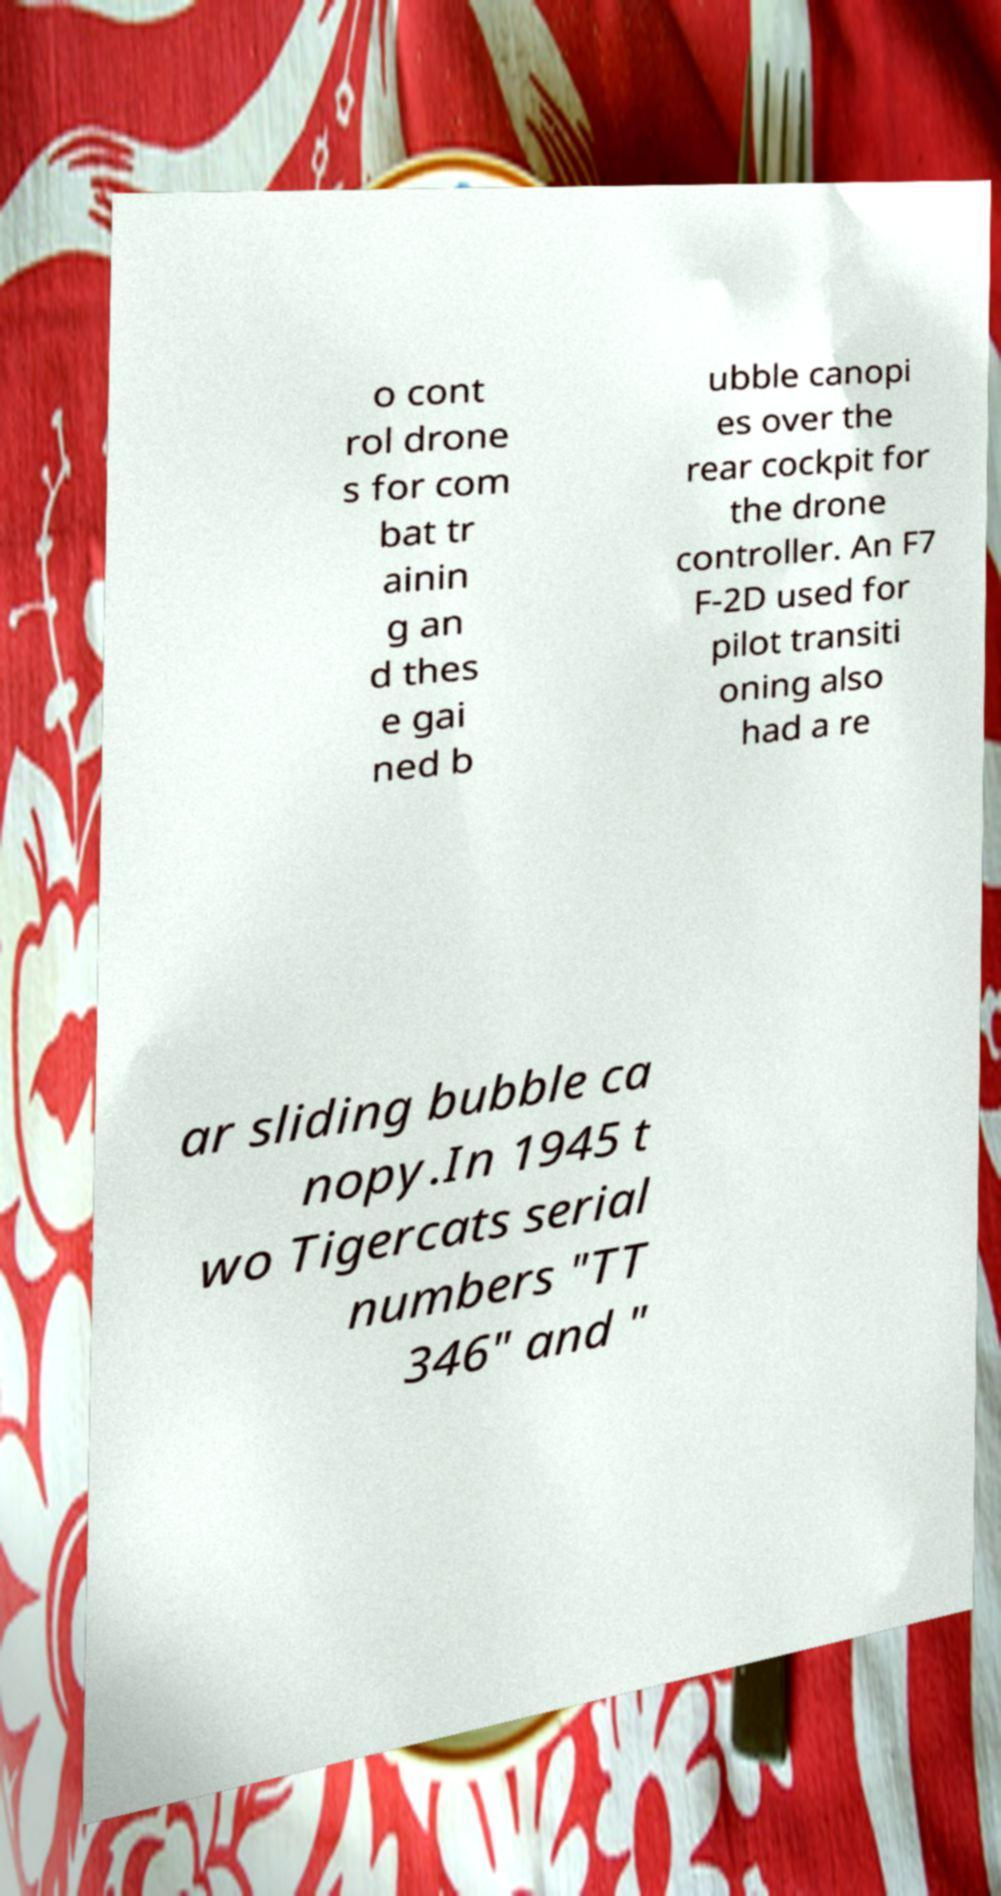Could you extract and type out the text from this image? o cont rol drone s for com bat tr ainin g an d thes e gai ned b ubble canopi es over the rear cockpit for the drone controller. An F7 F-2D used for pilot transiti oning also had a re ar sliding bubble ca nopy.In 1945 t wo Tigercats serial numbers "TT 346" and " 